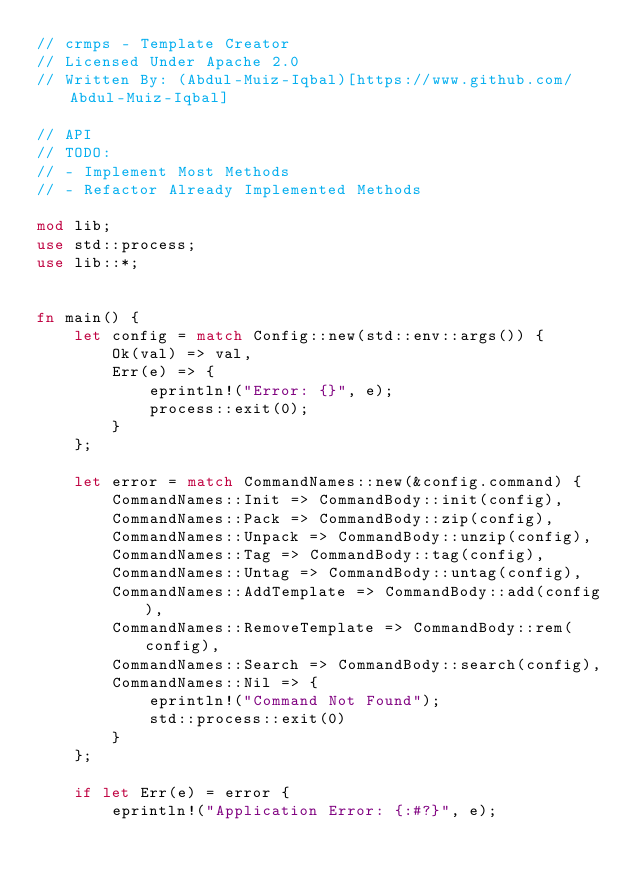<code> <loc_0><loc_0><loc_500><loc_500><_Rust_>// crmps - Template Creator
// Licensed Under Apache 2.0
// Written By: (Abdul-Muiz-Iqbal)[https://www.github.com/Abdul-Muiz-Iqbal]

// API
// TODO:
// - Implement Most Methods
// - Refactor Already Implemented Methods

mod lib;
use std::process;
use lib::*;


fn main() {
    let config = match Config::new(std::env::args()) {
        Ok(val) => val,
        Err(e) => {
            eprintln!("Error: {}", e);
            process::exit(0);
        }
    };
    
    let error = match CommandNames::new(&config.command) {
        CommandNames::Init => CommandBody::init(config),
        CommandNames::Pack => CommandBody::zip(config),
        CommandNames::Unpack => CommandBody::unzip(config),
        CommandNames::Tag => CommandBody::tag(config),
        CommandNames::Untag => CommandBody::untag(config),
        CommandNames::AddTemplate => CommandBody::add(config),
        CommandNames::RemoveTemplate => CommandBody::rem(config),
        CommandNames::Search => CommandBody::search(config),
        CommandNames::Nil => {
            eprintln!("Command Not Found");
            std::process::exit(0)
        }
    };

    if let Err(e) = error {
        eprintln!("Application Error: {:#?}", e);</code> 